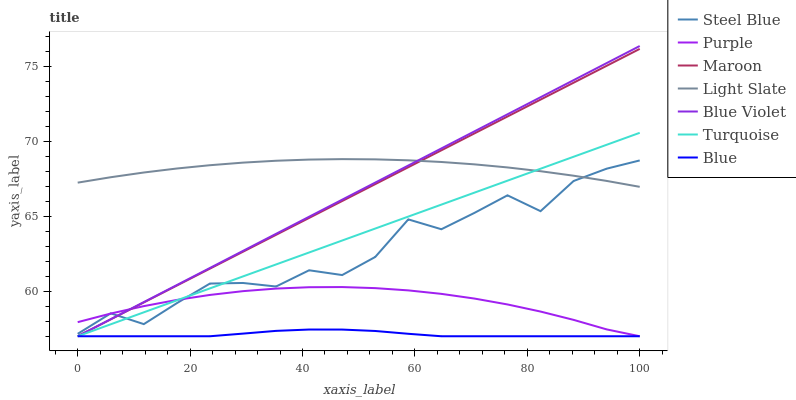Does Blue have the minimum area under the curve?
Answer yes or no. Yes. Does Light Slate have the maximum area under the curve?
Answer yes or no. Yes. Does Turquoise have the minimum area under the curve?
Answer yes or no. No. Does Turquoise have the maximum area under the curve?
Answer yes or no. No. Is Blue Violet the smoothest?
Answer yes or no. Yes. Is Steel Blue the roughest?
Answer yes or no. Yes. Is Turquoise the smoothest?
Answer yes or no. No. Is Turquoise the roughest?
Answer yes or no. No. Does Blue have the lowest value?
Answer yes or no. Yes. Does Steel Blue have the lowest value?
Answer yes or no. No. Does Blue Violet have the highest value?
Answer yes or no. Yes. Does Turquoise have the highest value?
Answer yes or no. No. Is Blue less than Steel Blue?
Answer yes or no. Yes. Is Steel Blue greater than Blue?
Answer yes or no. Yes. Does Steel Blue intersect Purple?
Answer yes or no. Yes. Is Steel Blue less than Purple?
Answer yes or no. No. Is Steel Blue greater than Purple?
Answer yes or no. No. Does Blue intersect Steel Blue?
Answer yes or no. No. 